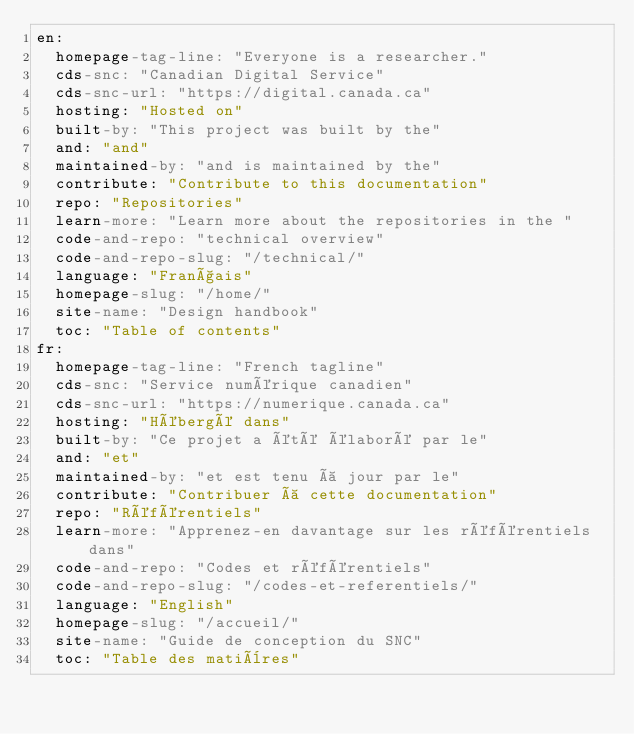Convert code to text. <code><loc_0><loc_0><loc_500><loc_500><_YAML_>en:
  homepage-tag-line: "Everyone is a researcher."
  cds-snc: "Canadian Digital Service"
  cds-snc-url: "https://digital.canada.ca"
  hosting: "Hosted on"
  built-by: "This project was built by the"
  and: "and"
  maintained-by: "and is maintained by the"
  contribute: "Contribute to this documentation"
  repo: "Repositories"
  learn-more: "Learn more about the repositories in the "
  code-and-repo: "technical overview"
  code-and-repo-slug: "/technical/"
  language: "Français"
  homepage-slug: "/home/"
  site-name: "Design handbook"
  toc: "Table of contents"
fr:
  homepage-tag-line: "French tagline"
  cds-snc: "Service numérique canadien"
  cds-snc-url: "https://numerique.canada.ca"
  hosting: "Hébergé dans"
  built-by: "Ce projet a été élaboré par le"
  and: "et"
  maintained-by: "et est tenu à jour par le"
  contribute: "Contribuer à cette documentation"
  repo: "Référentiels"
  learn-more: "Apprenez-en davantage sur les référentiels dans"
  code-and-repo: "Codes et référentiels"
  code-and-repo-slug: "/codes-et-referentiels/"
  language: "English"
  homepage-slug: "/accueil/"
  site-name: "Guide de conception du SNC"
  toc: "Table des matières"
</code> 